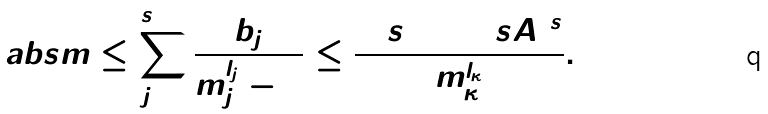Convert formula to latex. <formula><loc_0><loc_0><loc_500><loc_500>\ a b s { \L m } \leq \sum _ { j = 1 } ^ { s + 1 } \frac { b _ { j } } { m _ { j } ^ { l _ { j } } - 1 } \leq \frac { 2 ( s + 1 ) ( s A ) ^ { s } } { m _ { \kappa } ^ { l _ { \kappa } } } .</formula> 